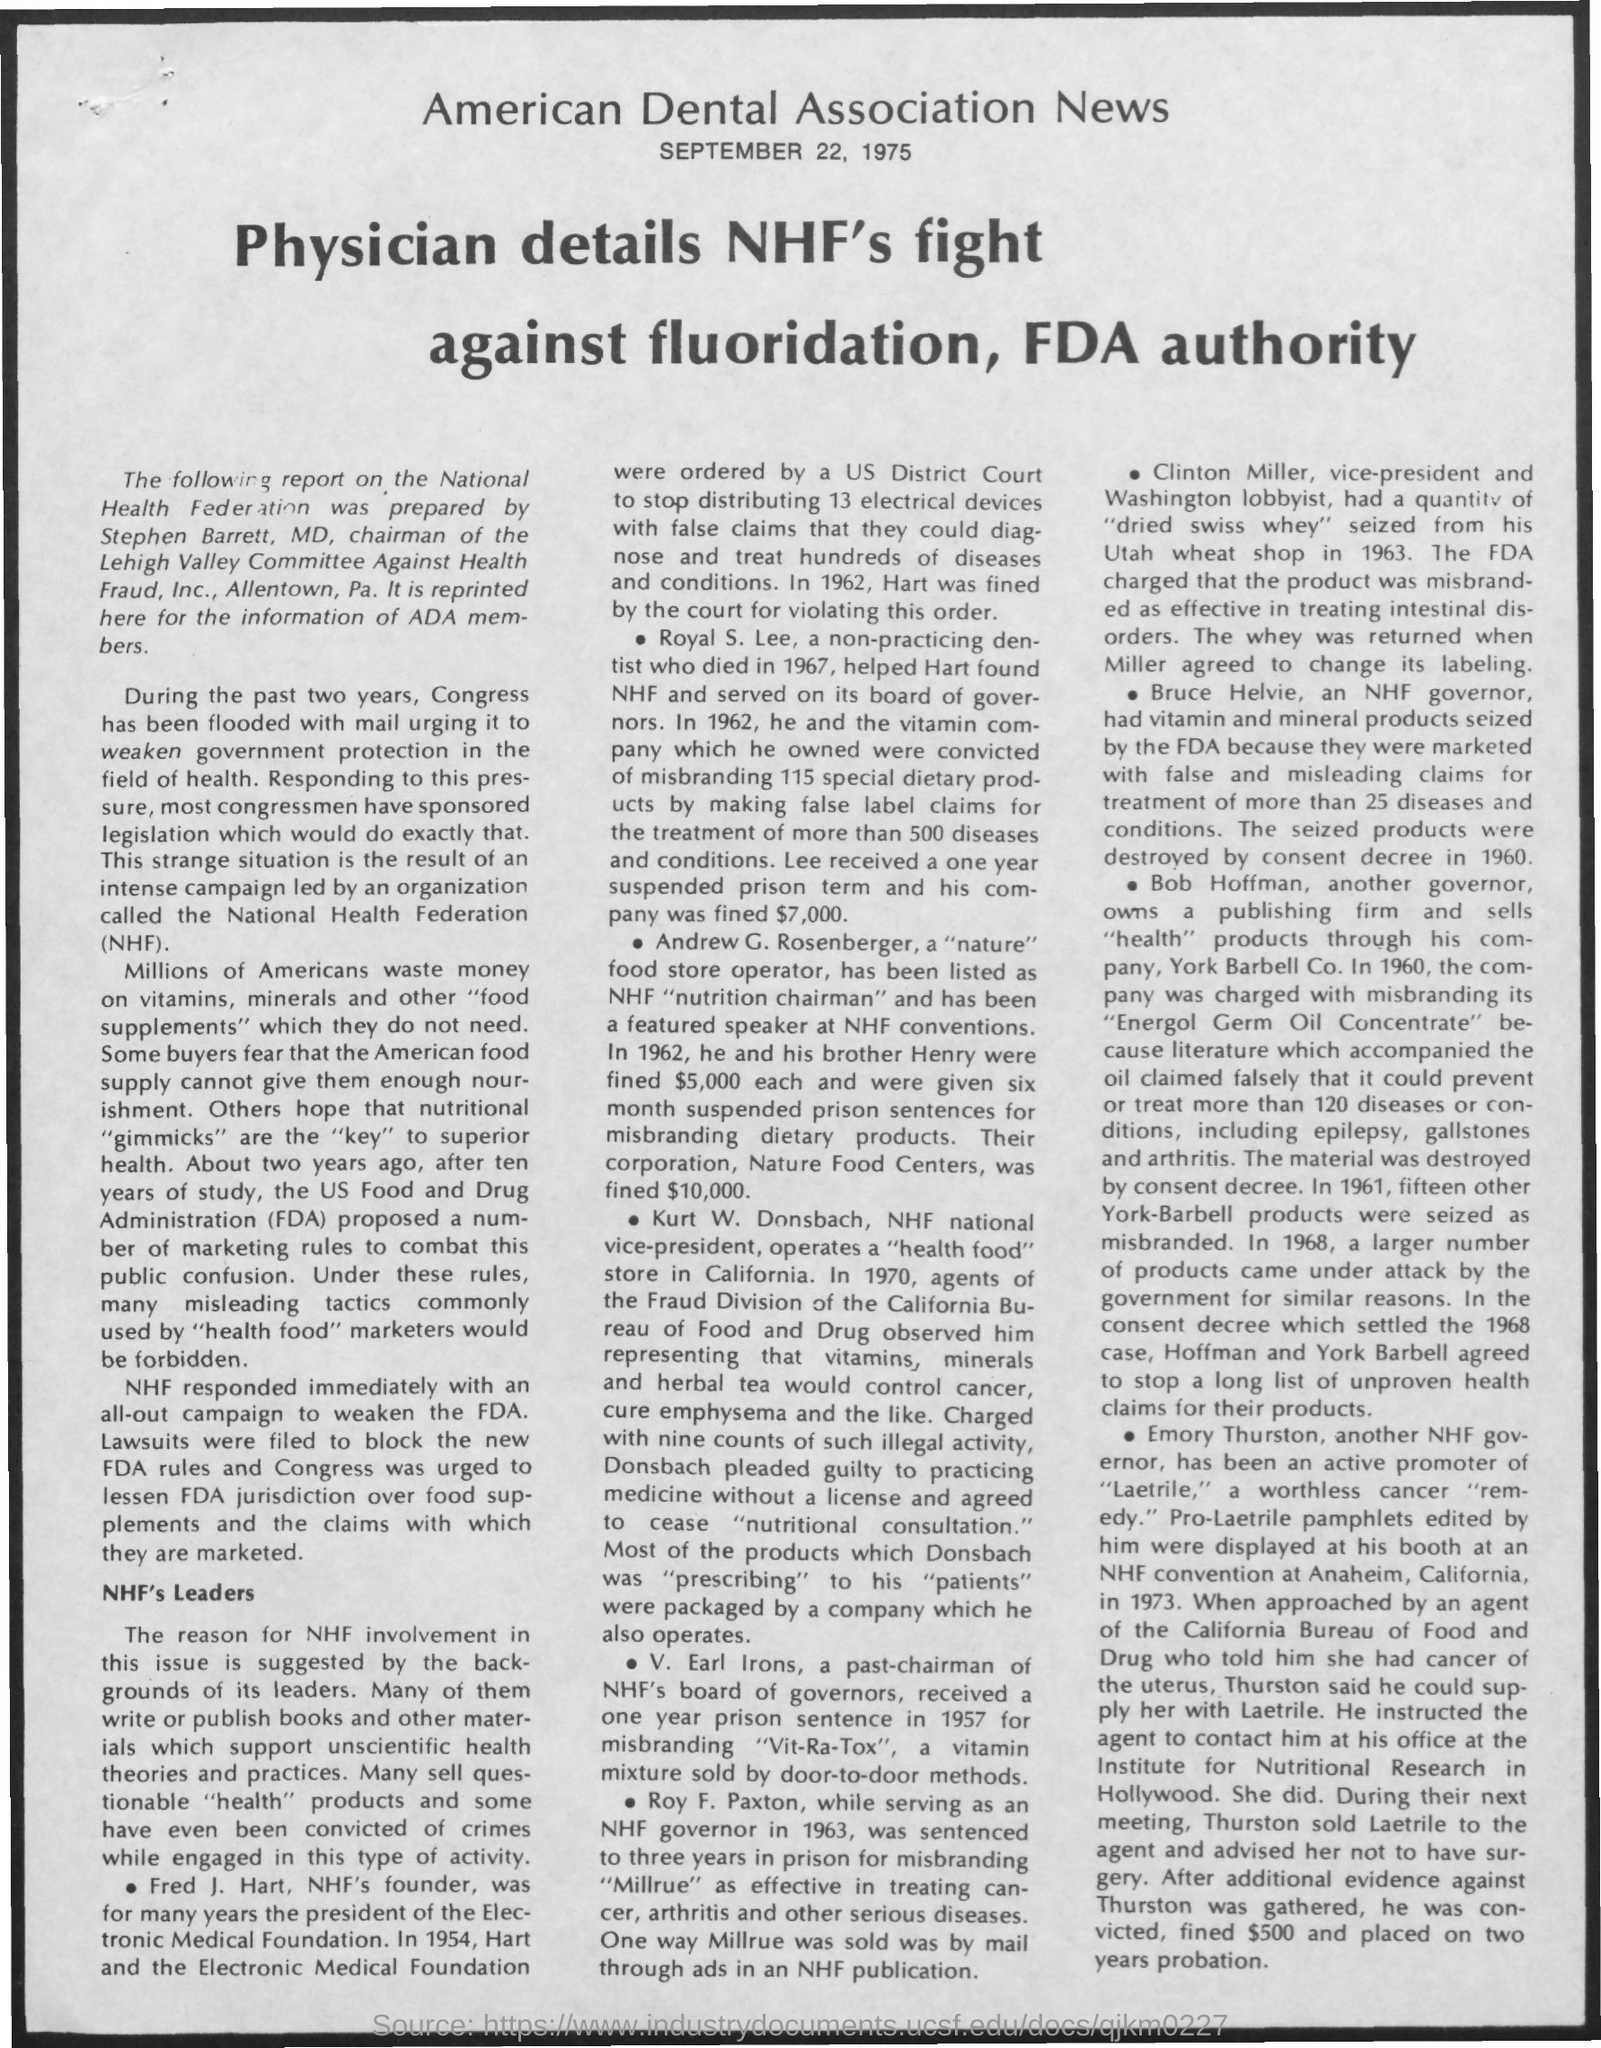Draw attention to some important aspects in this diagram. The Food and Drug Administration (FDA) is a government agency responsible for regulating and overseeing the safety and efficacy of food and drugs in the United States. The founder of NHF is Fred J. Hart. The news article is dated September 22, 1975. 